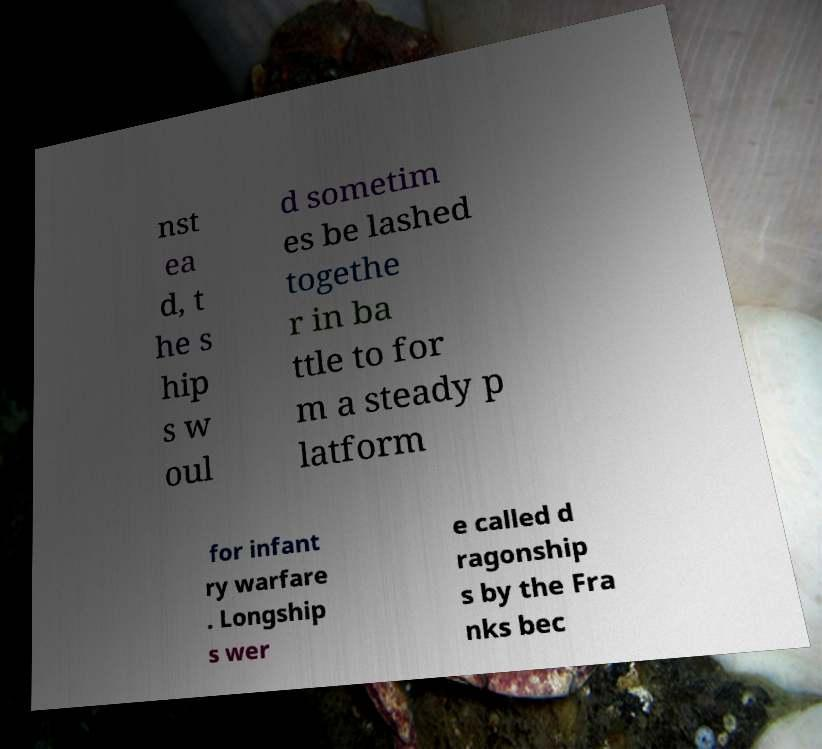Can you accurately transcribe the text from the provided image for me? nst ea d, t he s hip s w oul d sometim es be lashed togethe r in ba ttle to for m a steady p latform for infant ry warfare . Longship s wer e called d ragonship s by the Fra nks bec 